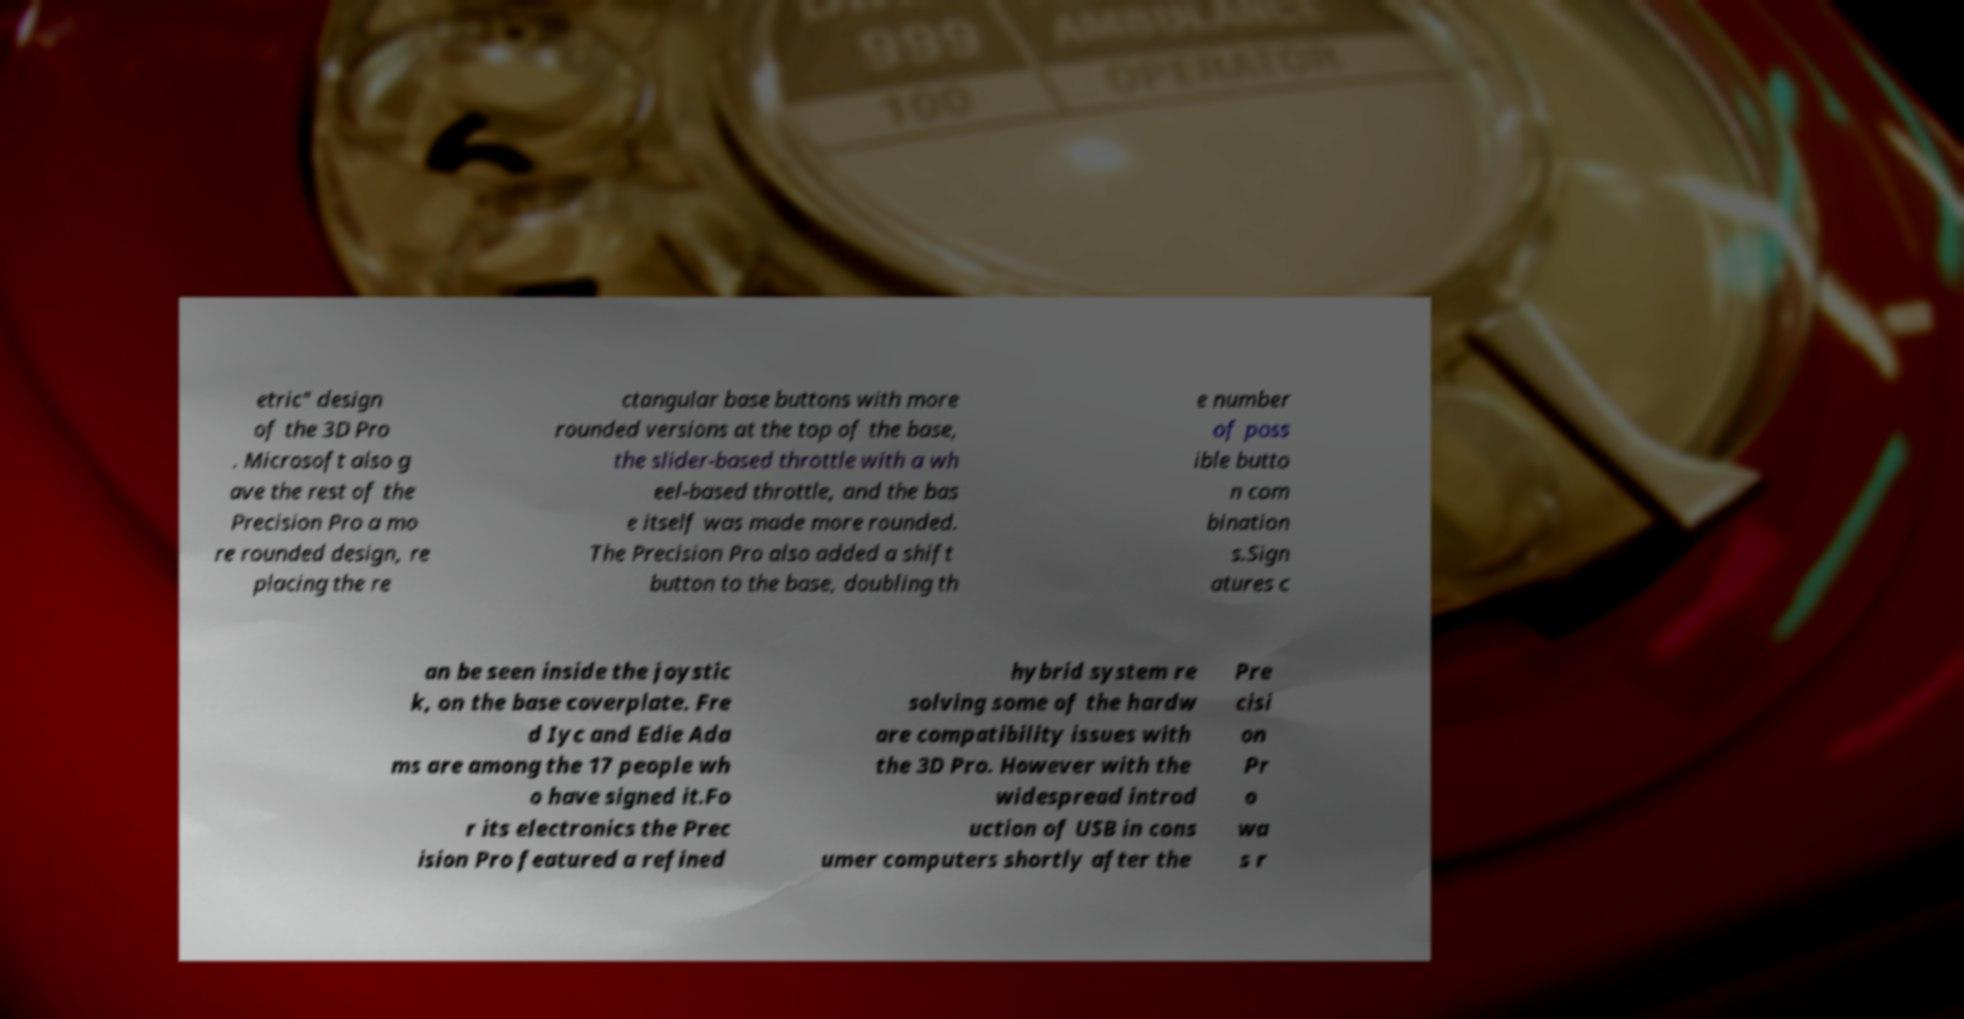For documentation purposes, I need the text within this image transcribed. Could you provide that? etric" design of the 3D Pro . Microsoft also g ave the rest of the Precision Pro a mo re rounded design, re placing the re ctangular base buttons with more rounded versions at the top of the base, the slider-based throttle with a wh eel-based throttle, and the bas e itself was made more rounded. The Precision Pro also added a shift button to the base, doubling th e number of poss ible butto n com bination s.Sign atures c an be seen inside the joystic k, on the base coverplate. Fre d Iyc and Edie Ada ms are among the 17 people wh o have signed it.Fo r its electronics the Prec ision Pro featured a refined hybrid system re solving some of the hardw are compatibility issues with the 3D Pro. However with the widespread introd uction of USB in cons umer computers shortly after the Pre cisi on Pr o wa s r 